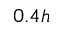Convert formula to latex. <formula><loc_0><loc_0><loc_500><loc_500>0 . 4 h</formula> 